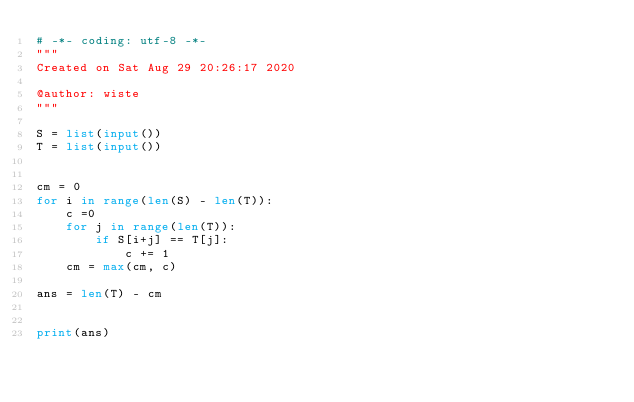<code> <loc_0><loc_0><loc_500><loc_500><_Python_># -*- coding: utf-8 -*-
"""
Created on Sat Aug 29 20:26:17 2020

@author: wiste
"""

S = list(input())
T = list(input())


cm = 0
for i in range(len(S) - len(T)):
    c =0
    for j in range(len(T)):
        if S[i+j] == T[j]:
            c += 1
    cm = max(cm, c)

ans = len(T) - cm


print(ans)</code> 